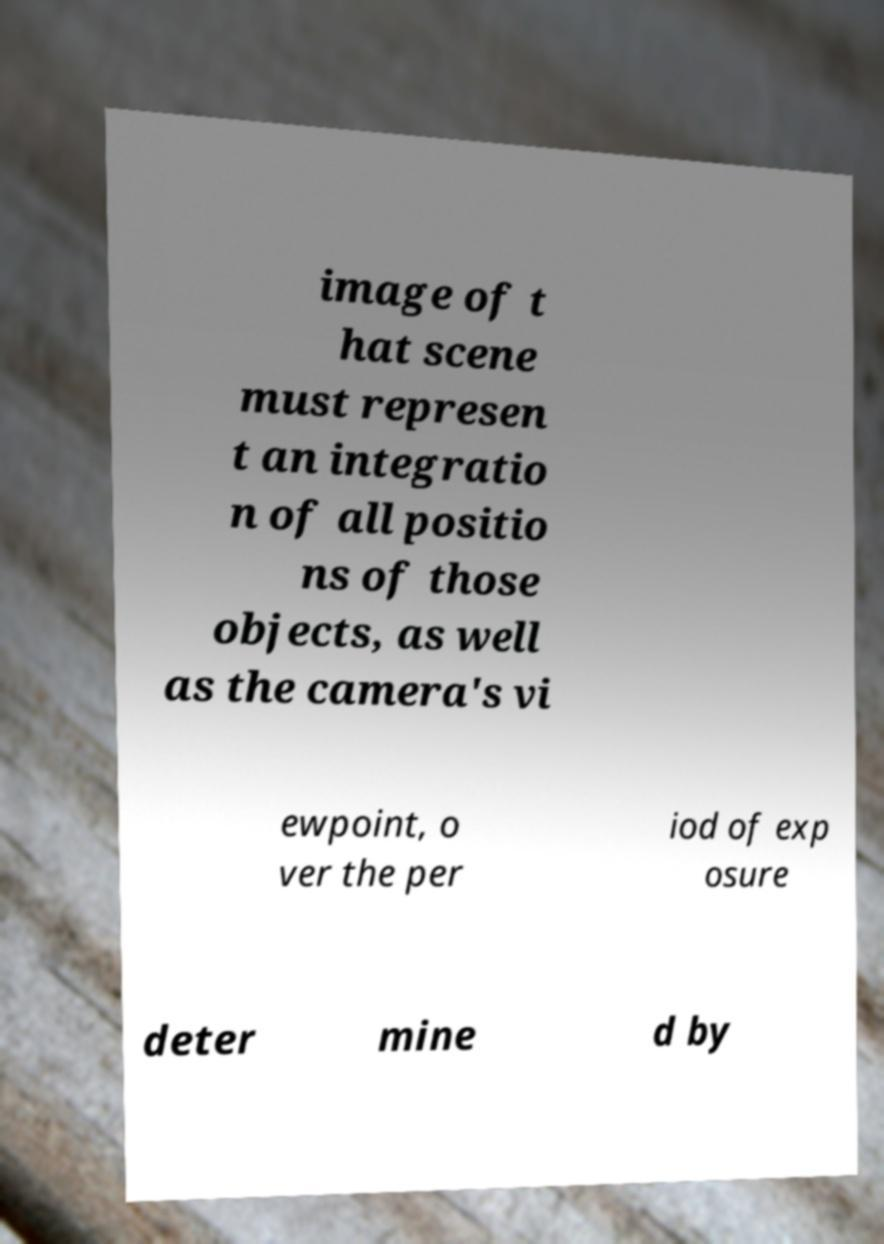I need the written content from this picture converted into text. Can you do that? image of t hat scene must represen t an integratio n of all positio ns of those objects, as well as the camera's vi ewpoint, o ver the per iod of exp osure deter mine d by 